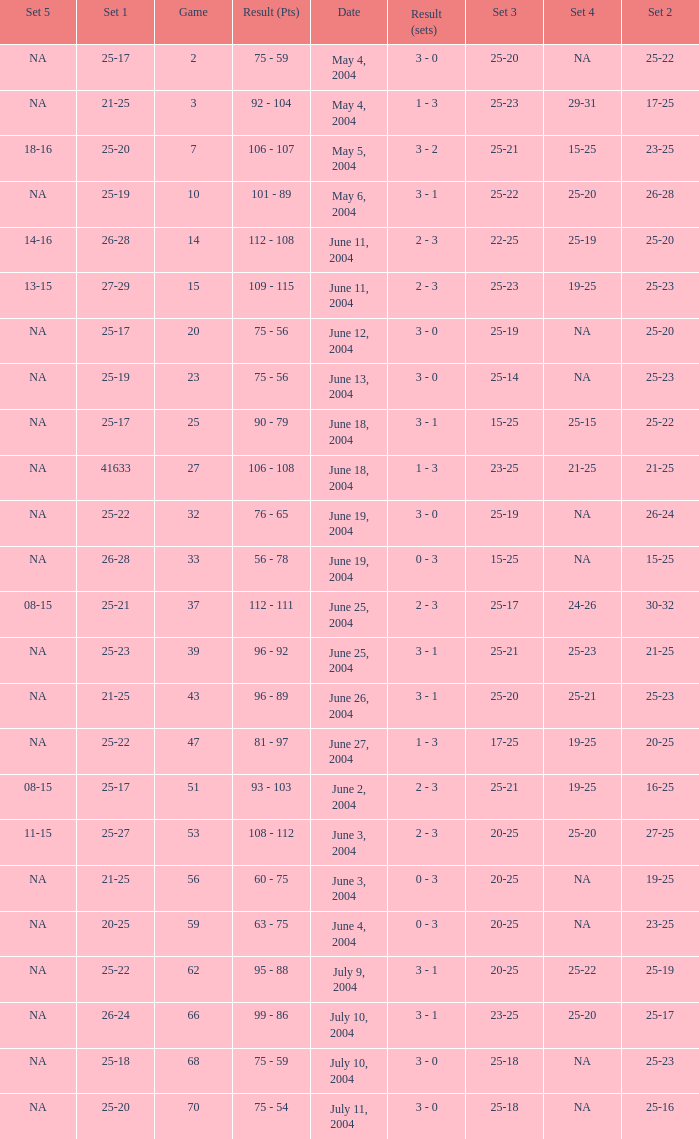What is the result of the game with a set 1 of 26-24? 99 - 86. 